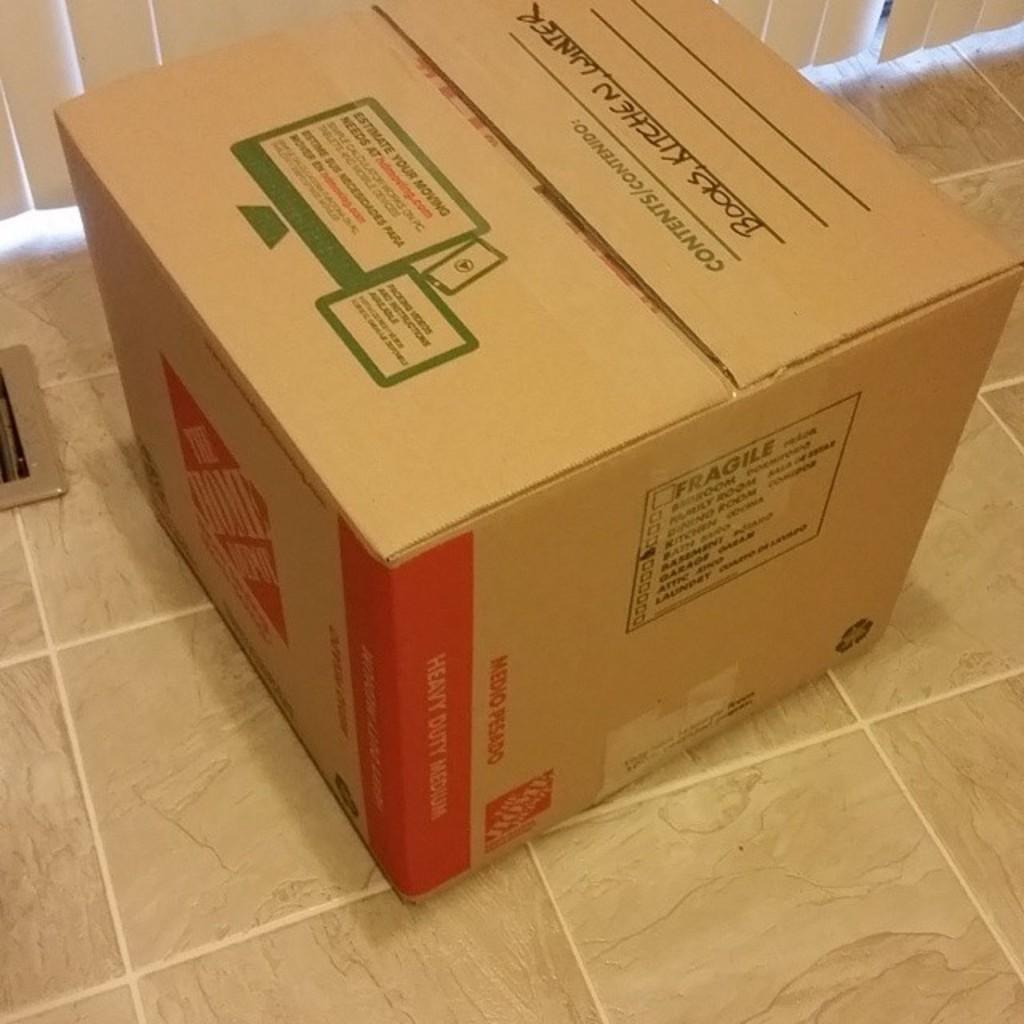<image>
Present a compact description of the photo's key features. A brown cardboard box labled in black marker with books,kitchen and winter. 